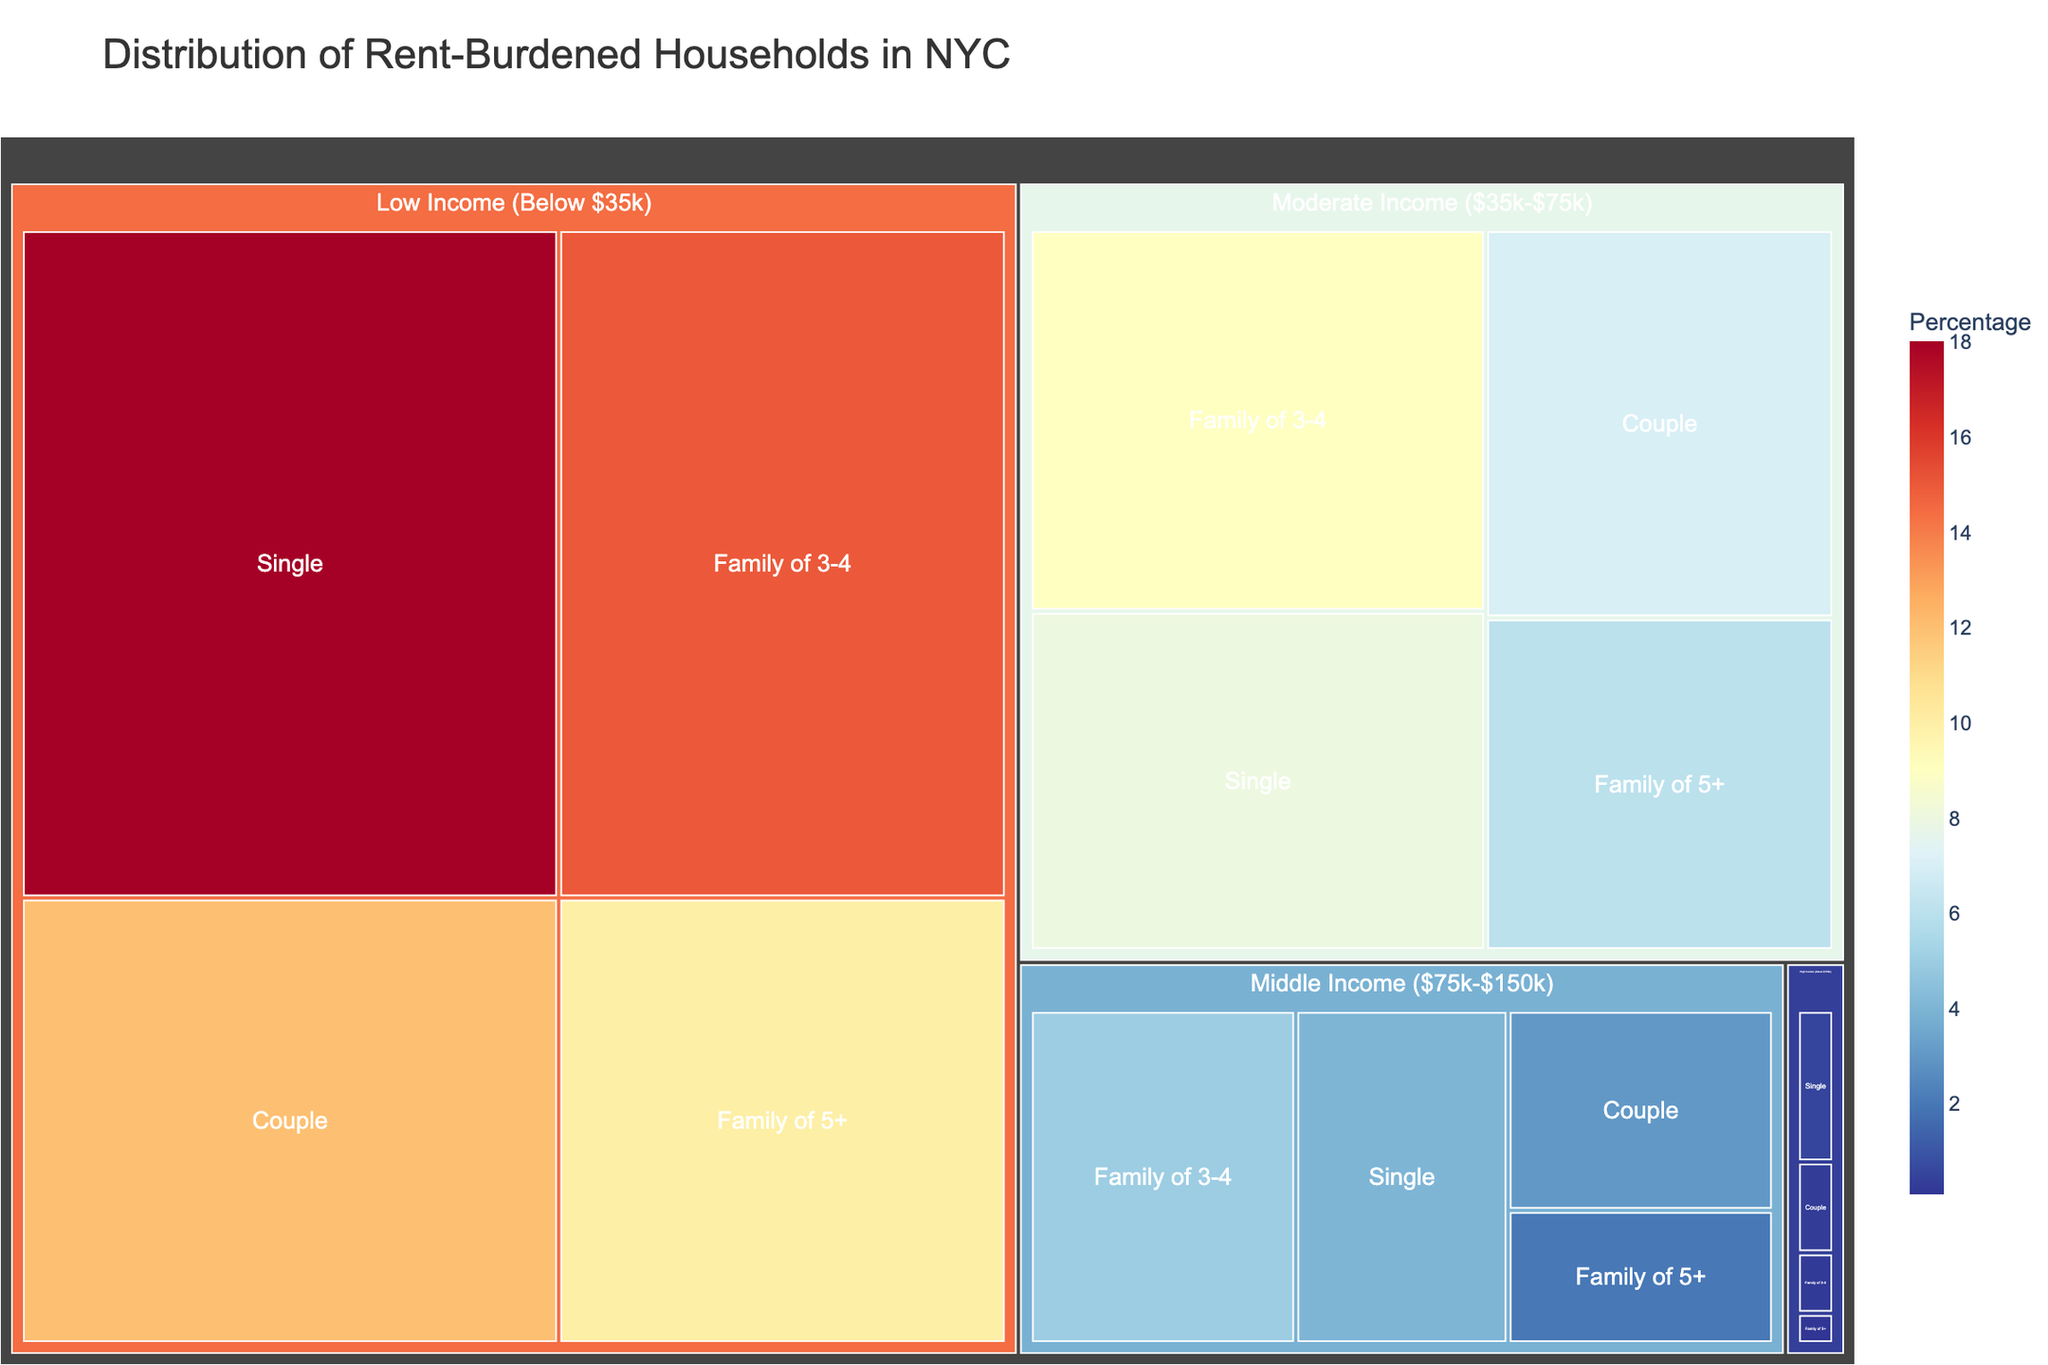What's the title of the figure? The title is usually text prominently displayed at the top of the figure. Here, it states the subject of the data visualized.
Answer: Distribution of Rent-Burdened Households in NYC Which income bracket and family size category has the highest percentage of rent-burdened households? Look for the category with the largest area (representing the highest percentage) within the treemap. The largest section typically stands out visually.
Answer: Low Income (Below $35k) - Single What's the combined percentage of rent-burdened families with 3-4 members from all income brackets? Identify the percentages for "Family of 3-4" in each income bracket and sum them up: Low Income (15) + Moderate Income (9) + Middle Income (5) + High Income (0.2).
Answer: 29.2% Compare the rent-burdened households percentage between Low Income Single and Middle Income Families of 3-4. Which is higher? Compare the areas or the values shown for Low Income Single (18%) and Middle Income Family of 3-4 (5%).
Answer: Low Income Single is higher Which family size category within the High Income bracket has the smallest percentage of rent-burdened households? Within the High Income bracket, check the values for each family size category and identify the smallest one.
Answer: Family of 5+ What is the percentage difference between Low Income Couples and Moderate Income Couples? Subtract the percentage value of Moderate Income Couples (7%) from Low Income Couples (12%).
Answer: 5% Within the Moderate Income bracket, what's the average percentage of rent-burdened households across all family sizes? Sum the percentages of all family sizes for Moderate Income (8+7+9+6 = 30) and then divide by 4 (number of categories).
Answer: 7.5% How many distinct family size categories are displayed in the treemap? Count the unique family size categories listed in the treemap sections. These are Single, Couple, Family of 3-4, Family of 5+.
Answer: 4 Compare the percentage of Low Income Families of 5+ to High Income Families of 3-4. How much greater is it? Subtract the percentage of High Income Families of 3-4 (0.2%) from Low Income Families of 5+ (10%).
Answer: 9.8% What's the total percentage of rent-burdened households within the Middle Income bracket? Sum the percentages of all household sizes within the Middle Income bracket: Single (4%) + Couple (3%) + Family of 3-4 (5%) + Family of 5+ (2%).
Answer: 14% 